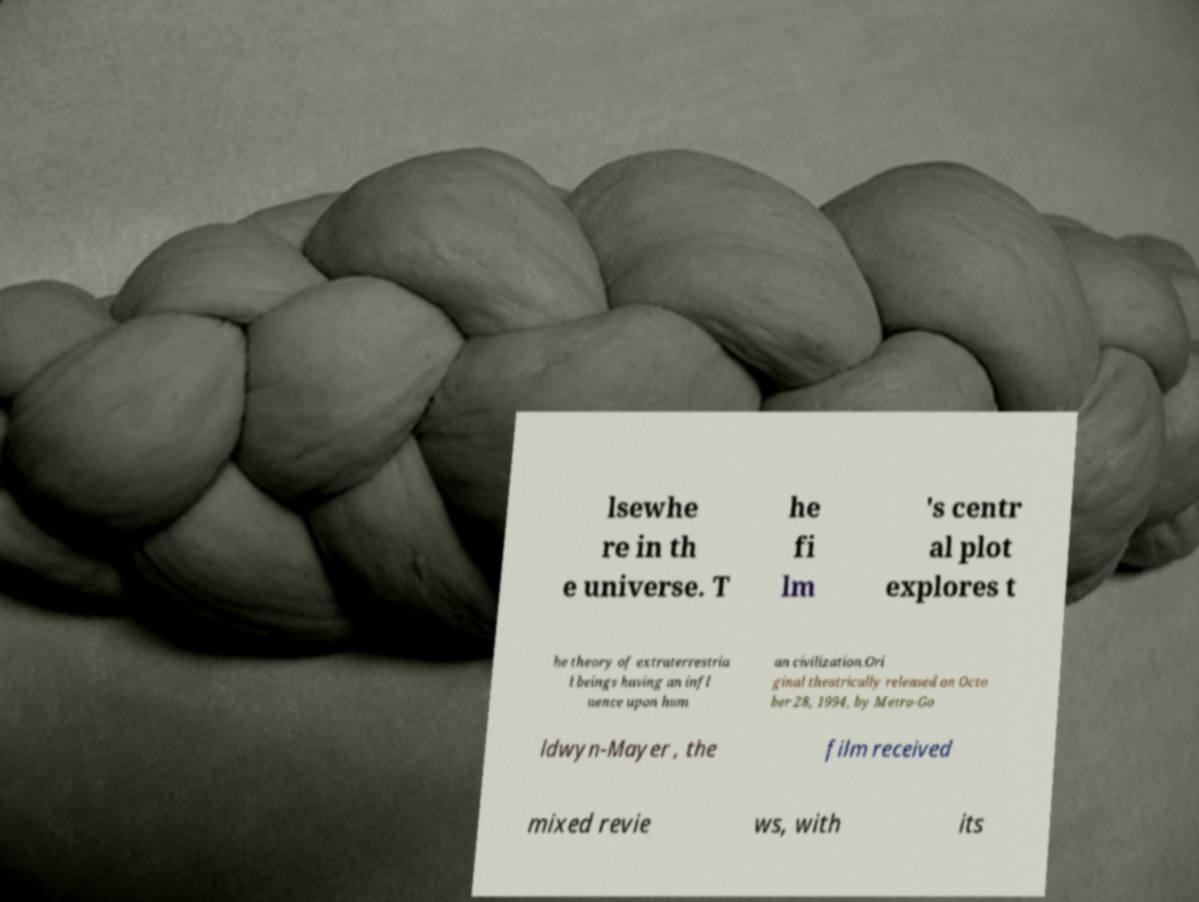Please read and relay the text visible in this image. What does it say? lsewhe re in th e universe. T he fi lm 's centr al plot explores t he theory of extraterrestria l beings having an infl uence upon hum an civilization.Ori ginal theatrically released on Octo ber 28, 1994, by Metro-Go ldwyn-Mayer , the film received mixed revie ws, with its 